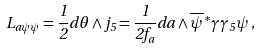Convert formula to latex. <formula><loc_0><loc_0><loc_500><loc_500>L _ { a \psi \psi } = \frac { 1 } { 2 } d \theta \wedge j _ { 5 } = \frac { 1 } { 2 f _ { a } } d a \wedge \overline { \psi } \, ^ { * } \gamma \gamma _ { 5 } \psi \, ,</formula> 